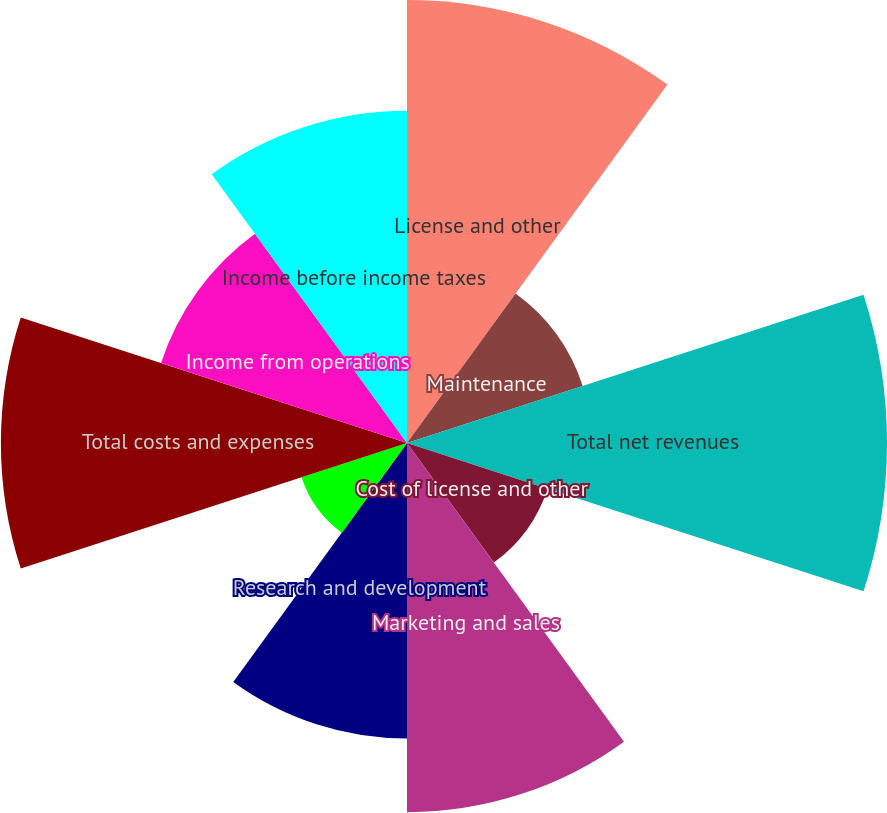Convert chart to OTSL. <chart><loc_0><loc_0><loc_500><loc_500><pie_chart><fcel>License and other<fcel>Maintenance<fcel>Total net revenues<fcel>Cost of license and other<fcel>Marketing and sales<fcel>Research and development<fcel>General and administrative<fcel>Total costs and expenses<fcel>Income from operations<fcel>Income before income taxes<nl><fcel>14.63%<fcel>6.1%<fcel>15.85%<fcel>4.88%<fcel>12.19%<fcel>9.76%<fcel>3.66%<fcel>13.41%<fcel>8.54%<fcel>10.97%<nl></chart> 